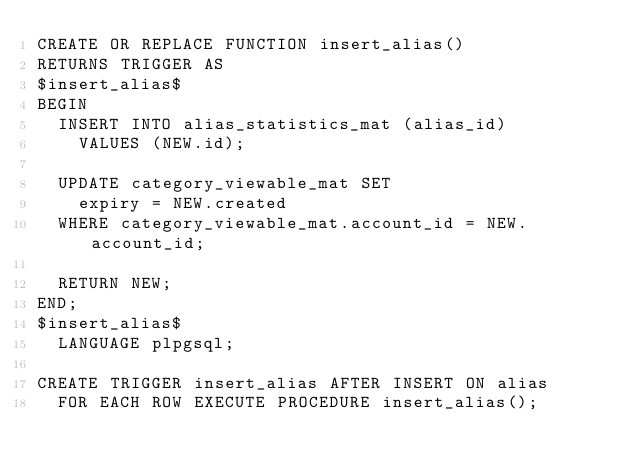<code> <loc_0><loc_0><loc_500><loc_500><_SQL_>CREATE OR REPLACE FUNCTION insert_alias()
RETURNS TRIGGER AS
$insert_alias$
BEGIN
  INSERT INTO alias_statistics_mat (alias_id)
    VALUES (NEW.id);

  UPDATE category_viewable_mat SET
    expiry = NEW.created
  WHERE category_viewable_mat.account_id = NEW.account_id;

  RETURN NEW;
END;
$insert_alias$
  LANGUAGE plpgsql;

CREATE TRIGGER insert_alias AFTER INSERT ON alias
  FOR EACH ROW EXECUTE PROCEDURE insert_alias();
</code> 